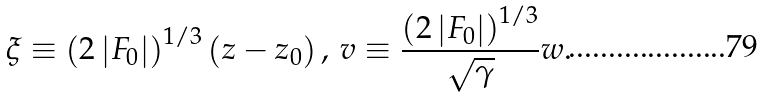Convert formula to latex. <formula><loc_0><loc_0><loc_500><loc_500>\xi \equiv \left ( 2 \left | F _ { 0 } \right | \right ) ^ { 1 / 3 } \left ( z - z _ { 0 } \right ) , \, v \equiv \frac { \left ( 2 \left | F _ { 0 } \right | \right ) ^ { 1 / 3 } } { \sqrt { \gamma } } w .</formula> 